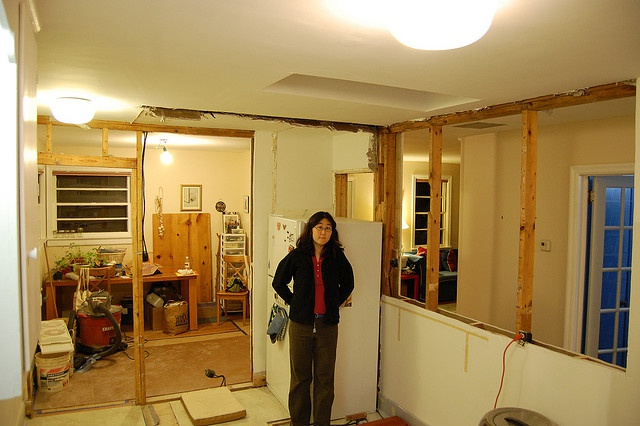Describe the objects in this image and their specific colors. I can see refrigerator in darkgray, tan, and olive tones, people in darkgray, black, maroon, brown, and olive tones, dining table in darkgray, brown, maroon, olive, and orange tones, chair in darkgray, brown, maroon, olive, and black tones, and couch in darkgray, black, maroon, and olive tones in this image. 